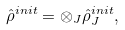Convert formula to latex. <formula><loc_0><loc_0><loc_500><loc_500>\hat { \rho } ^ { i n i t } = \otimes _ { J } \hat { \rho } ^ { i n i t } _ { J } ,</formula> 